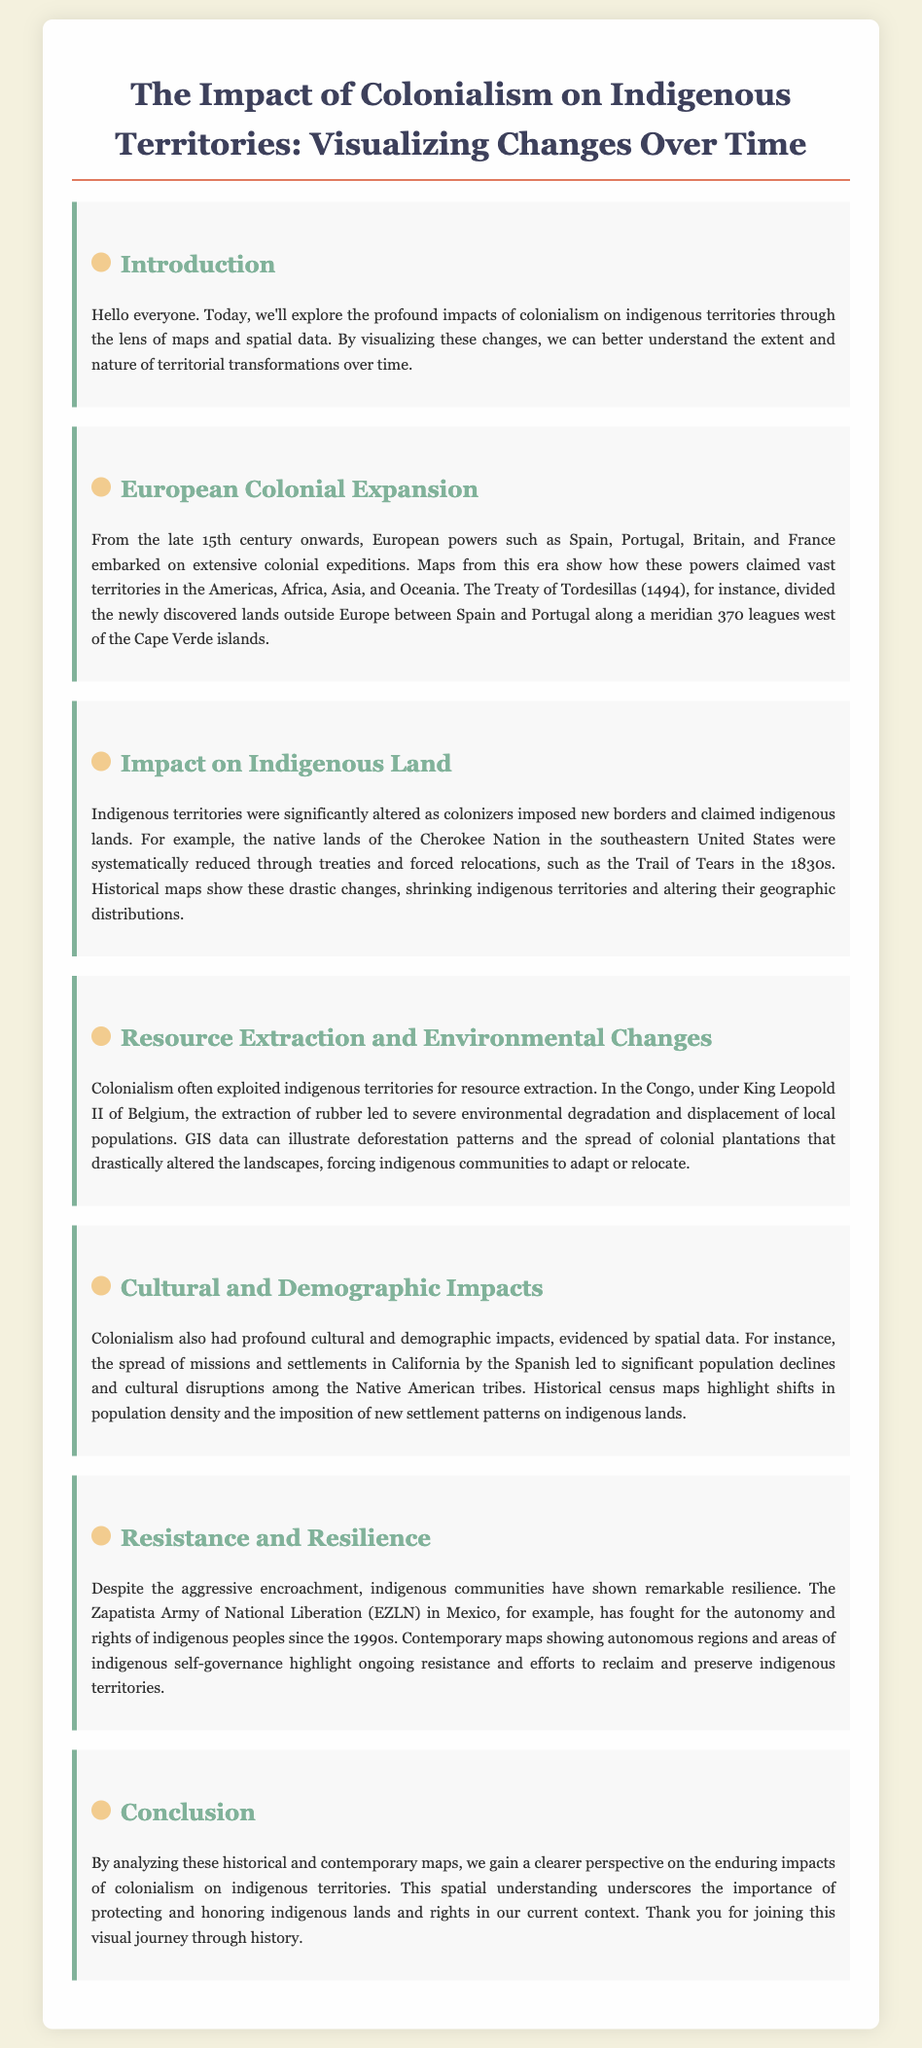What was the Treaty of Tordesillas? The Treaty of Tordesillas (1494) divided the newly discovered lands outside Europe between Spain and Portugal along a meridian 370 leagues west of the Cape Verde islands.
Answer: Treaty of Tordesillas (1494) What event significantly reduced the lands of the Cherokee Nation? The Cherokee Nation's lands were systematically reduced through treaties and forced relocations, such as the Trail of Tears in the 1830s.
Answer: Trail of Tears Which country's extraction of rubber caused severe environmental degradation in the Congo? Under King Leopold II of Belgium, the extraction of rubber led to severe environmental degradation and displacement of local populations.
Answer: Belgium What cultural impact did Spanish missions have in California? The spread of missions and settlements in California by the Spanish led to significant population declines and cultural disruptions among the Native American tribes.
Answer: Population declines What organization has fought for indigenous rights in Mexico since the 1990s? The Zapatista Army of National Liberation (EZLN) in Mexico has fought for the autonomy and rights of indigenous peoples since the 1990s.
Answer: EZLN 